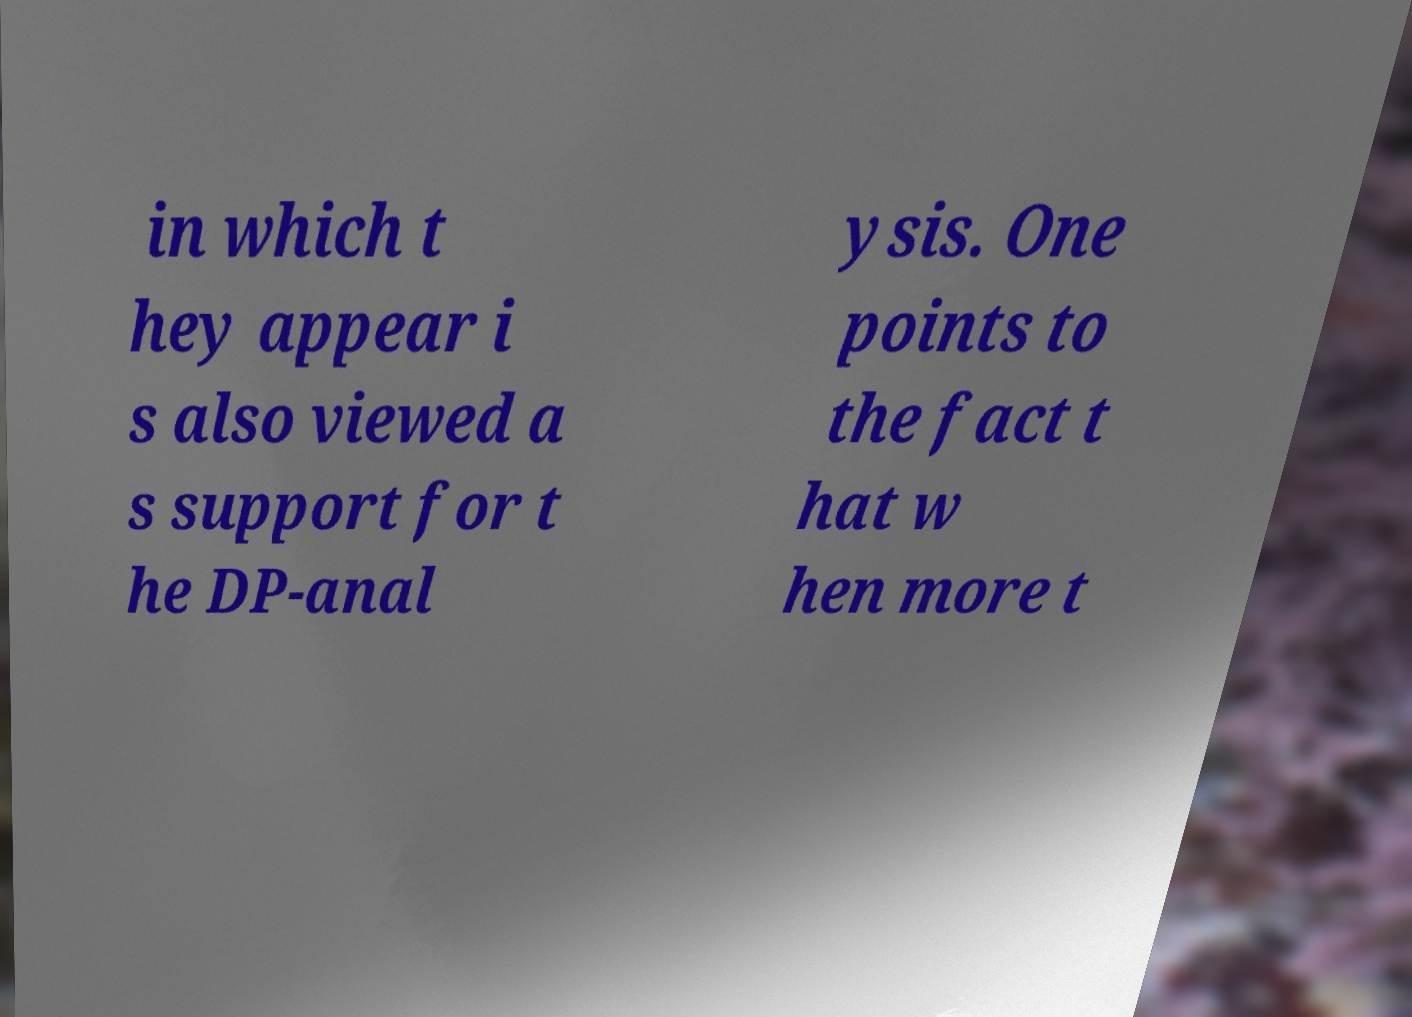Can you accurately transcribe the text from the provided image for me? in which t hey appear i s also viewed a s support for t he DP-anal ysis. One points to the fact t hat w hen more t 